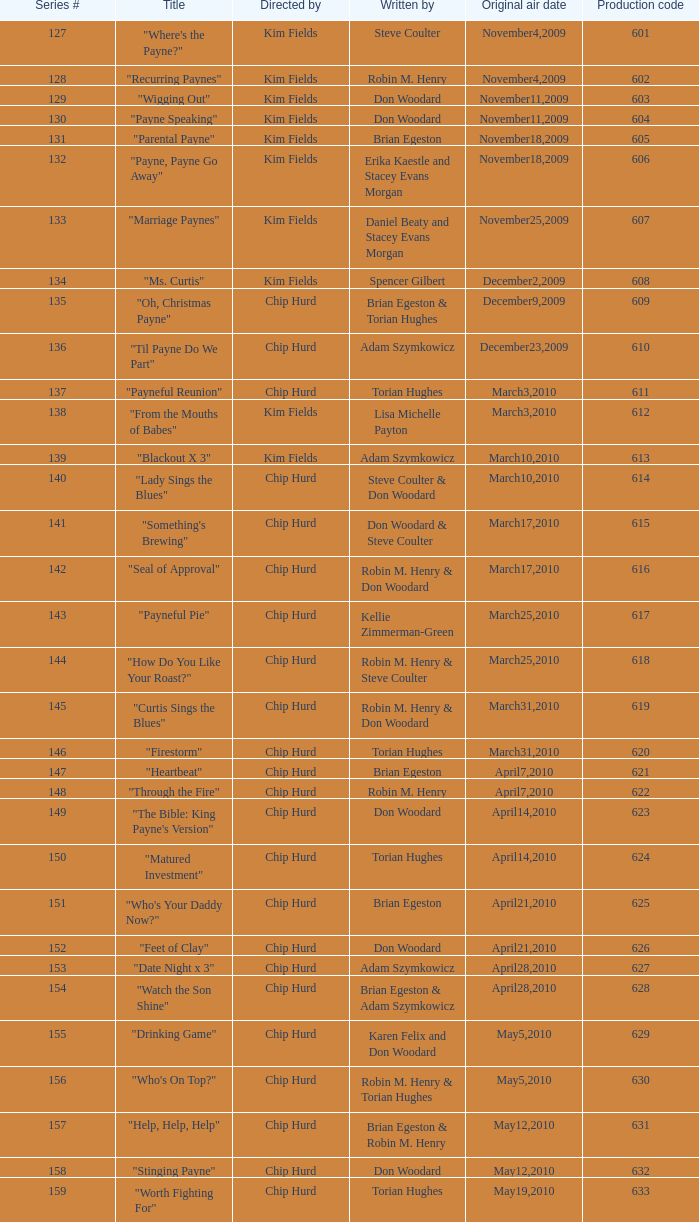What is the original air date of the episode written by Karen Felix and Don Woodard? May5,2010. 